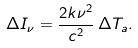<formula> <loc_0><loc_0><loc_500><loc_500>\Delta I _ { \nu } = \frac { 2 k \nu ^ { 2 } } { c ^ { 2 } } \, \Delta T _ { a } .</formula> 